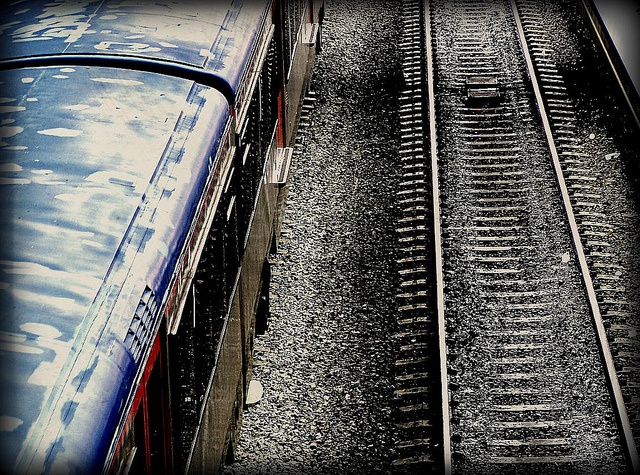Describe the objects in this image and their specific colors. I can see a train in black, lightgray, darkgray, and gray tones in this image. 